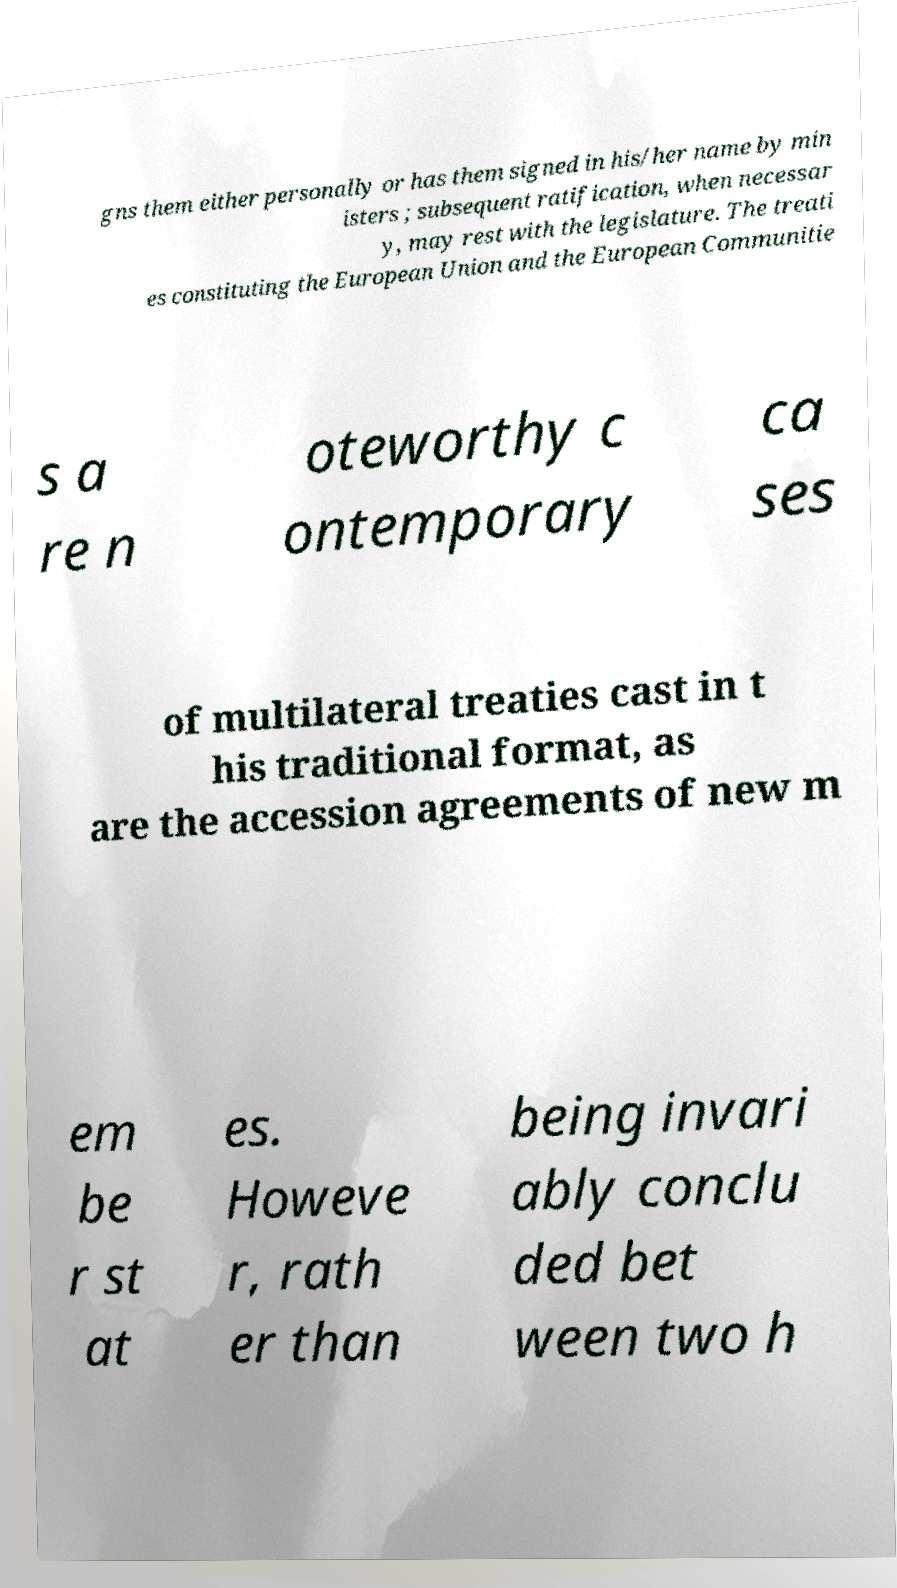Could you extract and type out the text from this image? gns them either personally or has them signed in his/her name by min isters ; subsequent ratification, when necessar y, may rest with the legislature. The treati es constituting the European Union and the European Communitie s a re n oteworthy c ontemporary ca ses of multilateral treaties cast in t his traditional format, as are the accession agreements of new m em be r st at es. Howeve r, rath er than being invari ably conclu ded bet ween two h 